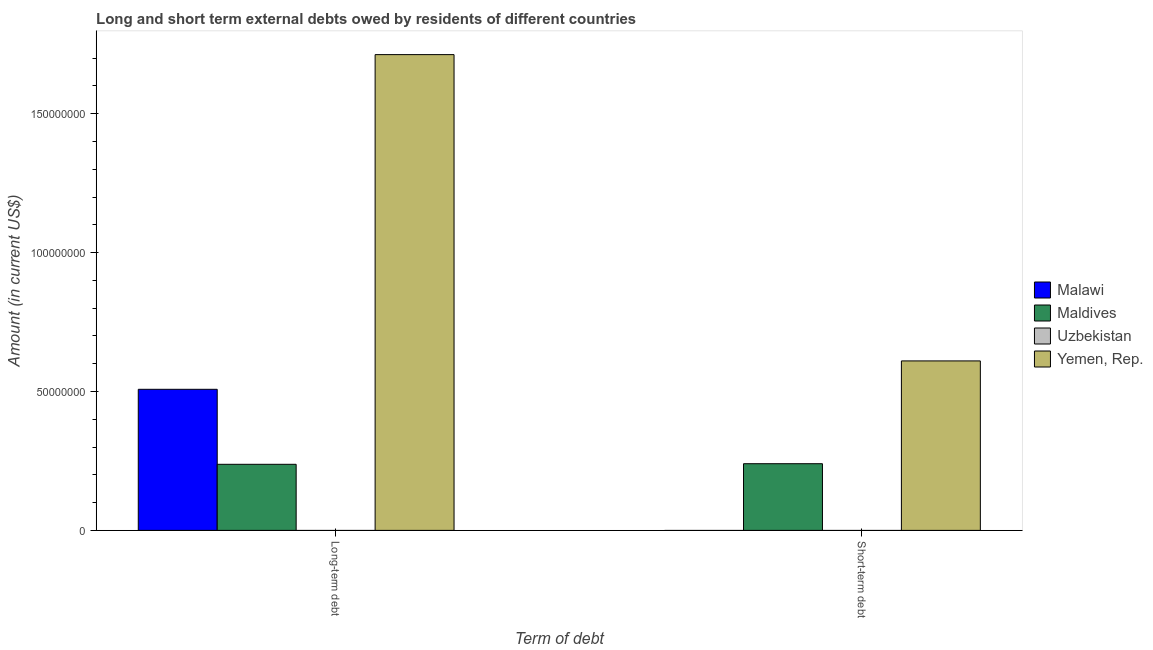How many groups of bars are there?
Provide a short and direct response. 2. Are the number of bars on each tick of the X-axis equal?
Your answer should be compact. No. How many bars are there on the 2nd tick from the left?
Your answer should be very brief. 2. What is the label of the 2nd group of bars from the left?
Your answer should be compact. Short-term debt. What is the long-term debts owed by residents in Maldives?
Keep it short and to the point. 2.38e+07. Across all countries, what is the maximum short-term debts owed by residents?
Your answer should be compact. 6.10e+07. Across all countries, what is the minimum short-term debts owed by residents?
Provide a succinct answer. 0. In which country was the short-term debts owed by residents maximum?
Give a very brief answer. Yemen, Rep. What is the total long-term debts owed by residents in the graph?
Ensure brevity in your answer.  2.46e+08. What is the difference between the short-term debts owed by residents in Maldives and that in Yemen, Rep.?
Offer a very short reply. -3.70e+07. What is the average long-term debts owed by residents per country?
Offer a terse response. 6.15e+07. What is the difference between the short-term debts owed by residents and long-term debts owed by residents in Maldives?
Your answer should be very brief. 2.14e+05. In how many countries, is the long-term debts owed by residents greater than 140000000 US$?
Offer a very short reply. 1. What is the ratio of the long-term debts owed by residents in Maldives to that in Yemen, Rep.?
Provide a succinct answer. 0.14. Is the long-term debts owed by residents in Yemen, Rep. less than that in Malawi?
Provide a short and direct response. No. In how many countries, is the long-term debts owed by residents greater than the average long-term debts owed by residents taken over all countries?
Keep it short and to the point. 1. How many bars are there?
Your answer should be compact. 5. Are all the bars in the graph horizontal?
Offer a very short reply. No. What is the difference between two consecutive major ticks on the Y-axis?
Provide a short and direct response. 5.00e+07. Does the graph contain any zero values?
Keep it short and to the point. Yes. Does the graph contain grids?
Your answer should be compact. No. Where does the legend appear in the graph?
Ensure brevity in your answer.  Center right. What is the title of the graph?
Ensure brevity in your answer.  Long and short term external debts owed by residents of different countries. What is the label or title of the X-axis?
Ensure brevity in your answer.  Term of debt. What is the label or title of the Y-axis?
Provide a succinct answer. Amount (in current US$). What is the Amount (in current US$) in Malawi in Long-term debt?
Your answer should be very brief. 5.08e+07. What is the Amount (in current US$) of Maldives in Long-term debt?
Offer a very short reply. 2.38e+07. What is the Amount (in current US$) of Yemen, Rep. in Long-term debt?
Give a very brief answer. 1.71e+08. What is the Amount (in current US$) of Maldives in Short-term debt?
Your response must be concise. 2.40e+07. What is the Amount (in current US$) of Uzbekistan in Short-term debt?
Provide a succinct answer. 0. What is the Amount (in current US$) of Yemen, Rep. in Short-term debt?
Provide a short and direct response. 6.10e+07. Across all Term of debt, what is the maximum Amount (in current US$) of Malawi?
Your response must be concise. 5.08e+07. Across all Term of debt, what is the maximum Amount (in current US$) in Maldives?
Provide a succinct answer. 2.40e+07. Across all Term of debt, what is the maximum Amount (in current US$) of Yemen, Rep.?
Offer a very short reply. 1.71e+08. Across all Term of debt, what is the minimum Amount (in current US$) of Malawi?
Your answer should be compact. 0. Across all Term of debt, what is the minimum Amount (in current US$) in Maldives?
Offer a terse response. 2.38e+07. Across all Term of debt, what is the minimum Amount (in current US$) in Yemen, Rep.?
Your response must be concise. 6.10e+07. What is the total Amount (in current US$) in Malawi in the graph?
Keep it short and to the point. 5.08e+07. What is the total Amount (in current US$) in Maldives in the graph?
Ensure brevity in your answer.  4.78e+07. What is the total Amount (in current US$) of Yemen, Rep. in the graph?
Keep it short and to the point. 2.32e+08. What is the difference between the Amount (in current US$) of Maldives in Long-term debt and that in Short-term debt?
Make the answer very short. -2.14e+05. What is the difference between the Amount (in current US$) of Yemen, Rep. in Long-term debt and that in Short-term debt?
Keep it short and to the point. 1.10e+08. What is the difference between the Amount (in current US$) of Malawi in Long-term debt and the Amount (in current US$) of Maldives in Short-term debt?
Give a very brief answer. 2.68e+07. What is the difference between the Amount (in current US$) in Malawi in Long-term debt and the Amount (in current US$) in Yemen, Rep. in Short-term debt?
Offer a very short reply. -1.02e+07. What is the difference between the Amount (in current US$) in Maldives in Long-term debt and the Amount (in current US$) in Yemen, Rep. in Short-term debt?
Your answer should be very brief. -3.72e+07. What is the average Amount (in current US$) of Malawi per Term of debt?
Make the answer very short. 2.54e+07. What is the average Amount (in current US$) of Maldives per Term of debt?
Make the answer very short. 2.39e+07. What is the average Amount (in current US$) in Yemen, Rep. per Term of debt?
Keep it short and to the point. 1.16e+08. What is the difference between the Amount (in current US$) in Malawi and Amount (in current US$) in Maldives in Long-term debt?
Your answer should be very brief. 2.70e+07. What is the difference between the Amount (in current US$) of Malawi and Amount (in current US$) of Yemen, Rep. in Long-term debt?
Provide a short and direct response. -1.20e+08. What is the difference between the Amount (in current US$) of Maldives and Amount (in current US$) of Yemen, Rep. in Long-term debt?
Provide a short and direct response. -1.47e+08. What is the difference between the Amount (in current US$) in Maldives and Amount (in current US$) in Yemen, Rep. in Short-term debt?
Your answer should be compact. -3.70e+07. What is the ratio of the Amount (in current US$) of Yemen, Rep. in Long-term debt to that in Short-term debt?
Your response must be concise. 2.81. What is the difference between the highest and the second highest Amount (in current US$) of Maldives?
Give a very brief answer. 2.14e+05. What is the difference between the highest and the second highest Amount (in current US$) of Yemen, Rep.?
Offer a very short reply. 1.10e+08. What is the difference between the highest and the lowest Amount (in current US$) of Malawi?
Keep it short and to the point. 5.08e+07. What is the difference between the highest and the lowest Amount (in current US$) in Maldives?
Your answer should be compact. 2.14e+05. What is the difference between the highest and the lowest Amount (in current US$) of Yemen, Rep.?
Keep it short and to the point. 1.10e+08. 